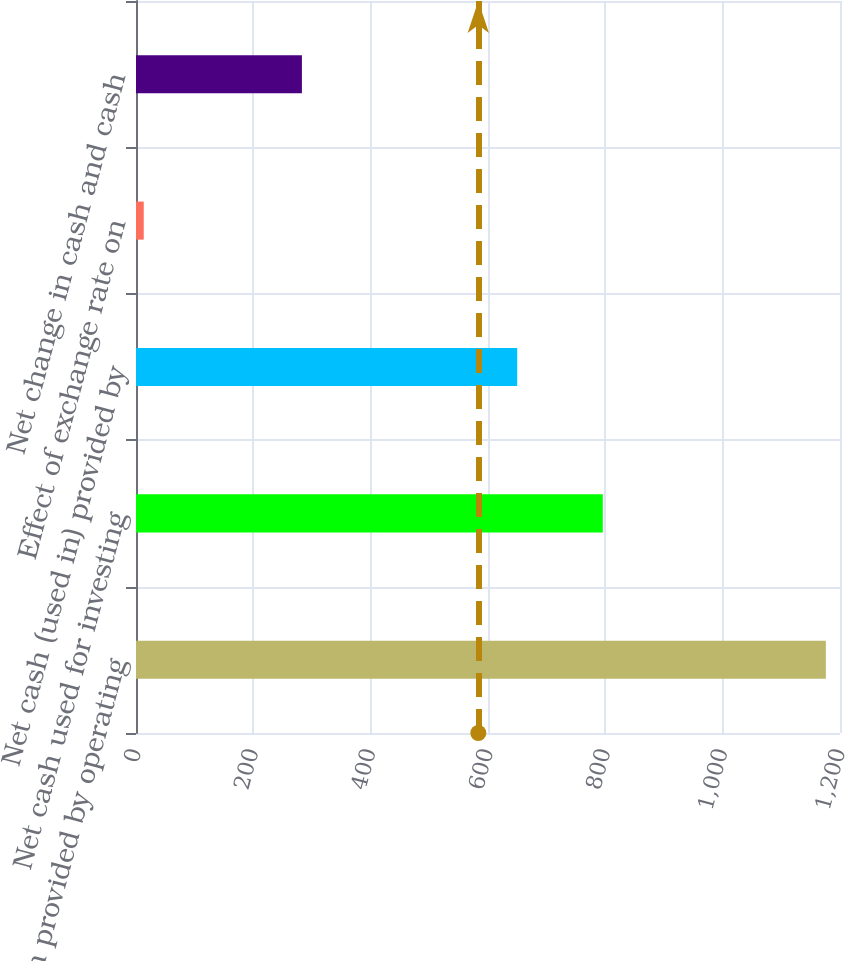Convert chart. <chart><loc_0><loc_0><loc_500><loc_500><bar_chart><fcel>Net cash provided by operating<fcel>Net cash used for investing<fcel>Net cash (used in) provided by<fcel>Effect of exchange rate on<fcel>Net change in cash and cash<nl><fcel>1175.9<fcel>795.7<fcel>649.8<fcel>13.2<fcel>282.8<nl></chart> 